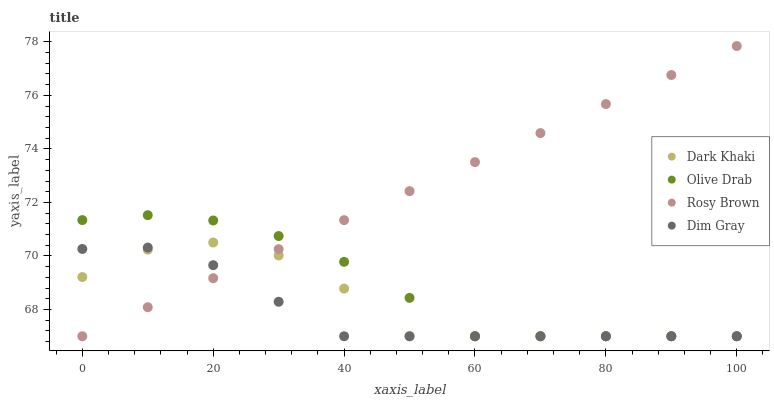Does Dim Gray have the minimum area under the curve?
Answer yes or no. Yes. Does Rosy Brown have the maximum area under the curve?
Answer yes or no. Yes. Does Rosy Brown have the minimum area under the curve?
Answer yes or no. No. Does Dim Gray have the maximum area under the curve?
Answer yes or no. No. Is Rosy Brown the smoothest?
Answer yes or no. Yes. Is Dark Khaki the roughest?
Answer yes or no. Yes. Is Dim Gray the smoothest?
Answer yes or no. No. Is Dim Gray the roughest?
Answer yes or no. No. Does Dark Khaki have the lowest value?
Answer yes or no. Yes. Does Rosy Brown have the highest value?
Answer yes or no. Yes. Does Dim Gray have the highest value?
Answer yes or no. No. Does Rosy Brown intersect Dim Gray?
Answer yes or no. Yes. Is Rosy Brown less than Dim Gray?
Answer yes or no. No. Is Rosy Brown greater than Dim Gray?
Answer yes or no. No. 